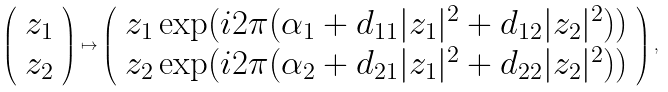<formula> <loc_0><loc_0><loc_500><loc_500>\left ( \begin{array} { l } z _ { 1 } \\ z _ { 2 } \end{array} \right ) \mapsto \left ( \begin{array} { l } z _ { 1 } \exp ( i 2 \pi ( \alpha _ { 1 } + d _ { 1 1 } | z _ { 1 } | ^ { 2 } + d _ { 1 2 } | z _ { 2 } | ^ { 2 } ) ) \\ z _ { 2 } \exp ( i 2 \pi ( \alpha _ { 2 } + d _ { 2 1 } | z _ { 1 } | ^ { 2 } + d _ { 2 2 } | z _ { 2 } | ^ { 2 } ) ) \end{array} \right ) ,</formula> 